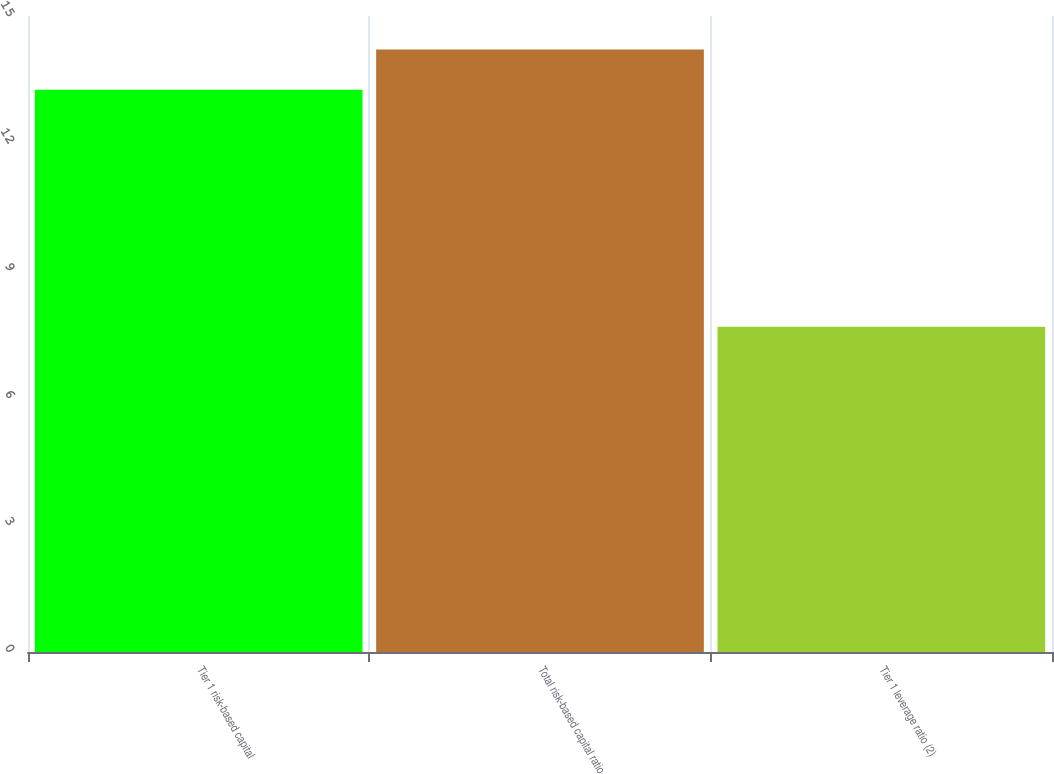Convert chart to OTSL. <chart><loc_0><loc_0><loc_500><loc_500><bar_chart><fcel>Tier 1 risk-based capital<fcel>Total risk-based capital ratio<fcel>Tier 1 leverage ratio (2)<nl><fcel>13.26<fcel>14.21<fcel>7.67<nl></chart> 